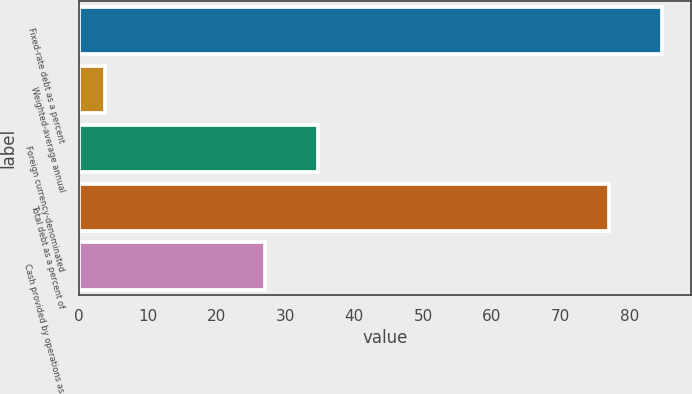Convert chart to OTSL. <chart><loc_0><loc_0><loc_500><loc_500><bar_chart><fcel>Fixed-rate debt as a percent<fcel>Weighted-average annual<fcel>Foreign currency-denominated<fcel>Total debt as a percent of<fcel>Cash provided by operations as<nl><fcel>84.72<fcel>3.8<fcel>34.72<fcel>77<fcel>27<nl></chart> 